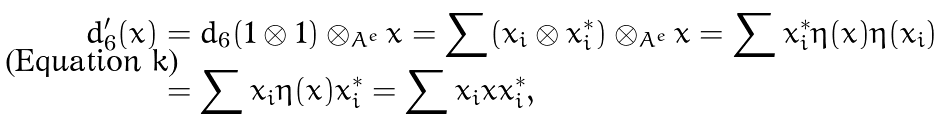<formula> <loc_0><loc_0><loc_500><loc_500>d _ { 6 } ^ { \prime } ( x ) & = d _ { 6 } ( 1 \otimes 1 ) \otimes _ { A ^ { e } } x = \sum ( x _ { i } \otimes x _ { i } ^ { * } ) \otimes _ { A ^ { e } } x = \sum x _ { i } ^ { * } \eta ( x ) \eta ( x _ { i } ) \\ & = \sum x _ { i } \eta ( x ) x _ { i } ^ { * } = \sum x _ { i } x x _ { i } ^ { * } ,</formula> 